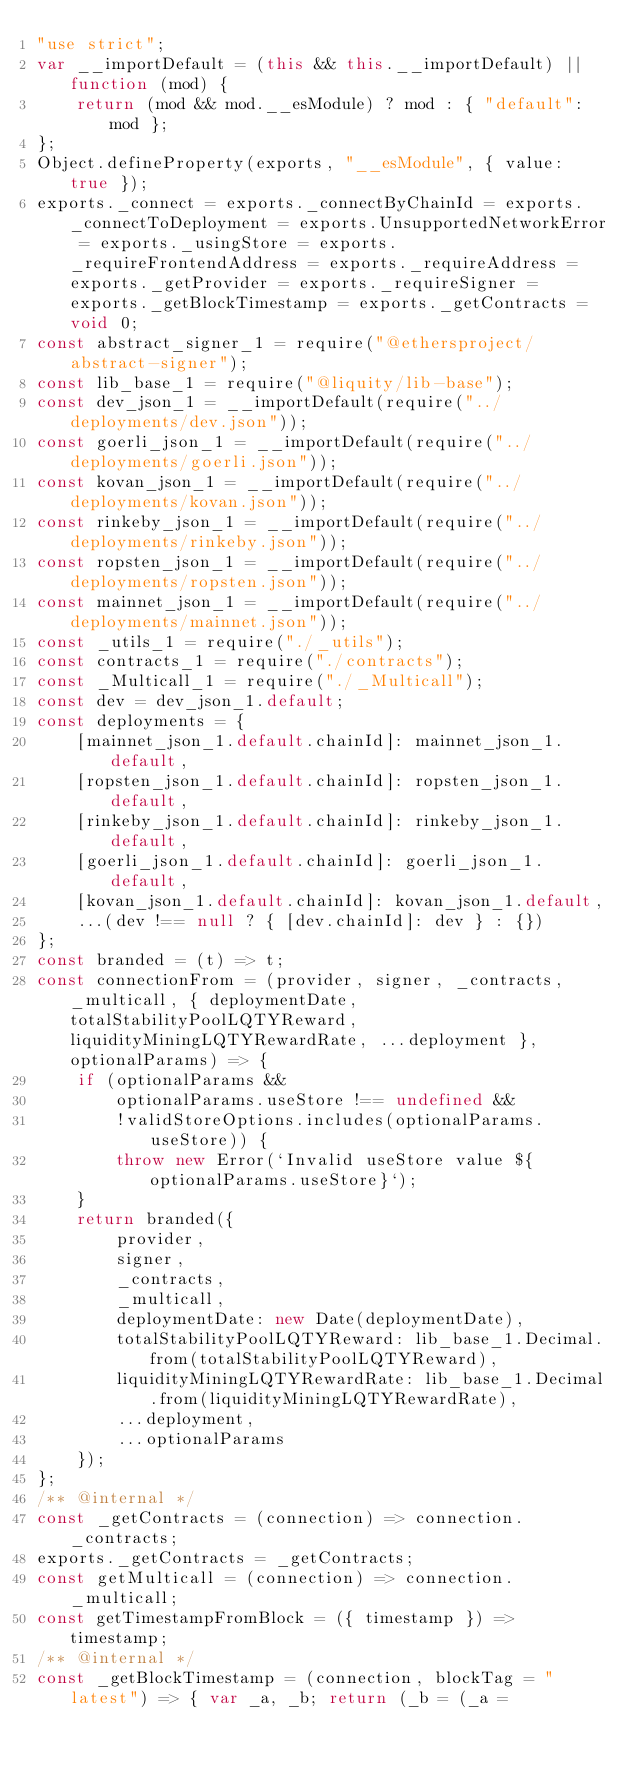Convert code to text. <code><loc_0><loc_0><loc_500><loc_500><_JavaScript_>"use strict";
var __importDefault = (this && this.__importDefault) || function (mod) {
    return (mod && mod.__esModule) ? mod : { "default": mod };
};
Object.defineProperty(exports, "__esModule", { value: true });
exports._connect = exports._connectByChainId = exports._connectToDeployment = exports.UnsupportedNetworkError = exports._usingStore = exports._requireFrontendAddress = exports._requireAddress = exports._getProvider = exports._requireSigner = exports._getBlockTimestamp = exports._getContracts = void 0;
const abstract_signer_1 = require("@ethersproject/abstract-signer");
const lib_base_1 = require("@liquity/lib-base");
const dev_json_1 = __importDefault(require("../deployments/dev.json"));
const goerli_json_1 = __importDefault(require("../deployments/goerli.json"));
const kovan_json_1 = __importDefault(require("../deployments/kovan.json"));
const rinkeby_json_1 = __importDefault(require("../deployments/rinkeby.json"));
const ropsten_json_1 = __importDefault(require("../deployments/ropsten.json"));
const mainnet_json_1 = __importDefault(require("../deployments/mainnet.json"));
const _utils_1 = require("./_utils");
const contracts_1 = require("./contracts");
const _Multicall_1 = require("./_Multicall");
const dev = dev_json_1.default;
const deployments = {
    [mainnet_json_1.default.chainId]: mainnet_json_1.default,
    [ropsten_json_1.default.chainId]: ropsten_json_1.default,
    [rinkeby_json_1.default.chainId]: rinkeby_json_1.default,
    [goerli_json_1.default.chainId]: goerli_json_1.default,
    [kovan_json_1.default.chainId]: kovan_json_1.default,
    ...(dev !== null ? { [dev.chainId]: dev } : {})
};
const branded = (t) => t;
const connectionFrom = (provider, signer, _contracts, _multicall, { deploymentDate, totalStabilityPoolLQTYReward, liquidityMiningLQTYRewardRate, ...deployment }, optionalParams) => {
    if (optionalParams &&
        optionalParams.useStore !== undefined &&
        !validStoreOptions.includes(optionalParams.useStore)) {
        throw new Error(`Invalid useStore value ${optionalParams.useStore}`);
    }
    return branded({
        provider,
        signer,
        _contracts,
        _multicall,
        deploymentDate: new Date(deploymentDate),
        totalStabilityPoolLQTYReward: lib_base_1.Decimal.from(totalStabilityPoolLQTYReward),
        liquidityMiningLQTYRewardRate: lib_base_1.Decimal.from(liquidityMiningLQTYRewardRate),
        ...deployment,
        ...optionalParams
    });
};
/** @internal */
const _getContracts = (connection) => connection._contracts;
exports._getContracts = _getContracts;
const getMulticall = (connection) => connection._multicall;
const getTimestampFromBlock = ({ timestamp }) => timestamp;
/** @internal */
const _getBlockTimestamp = (connection, blockTag = "latest") => { var _a, _b; return (_b = (_a = </code> 